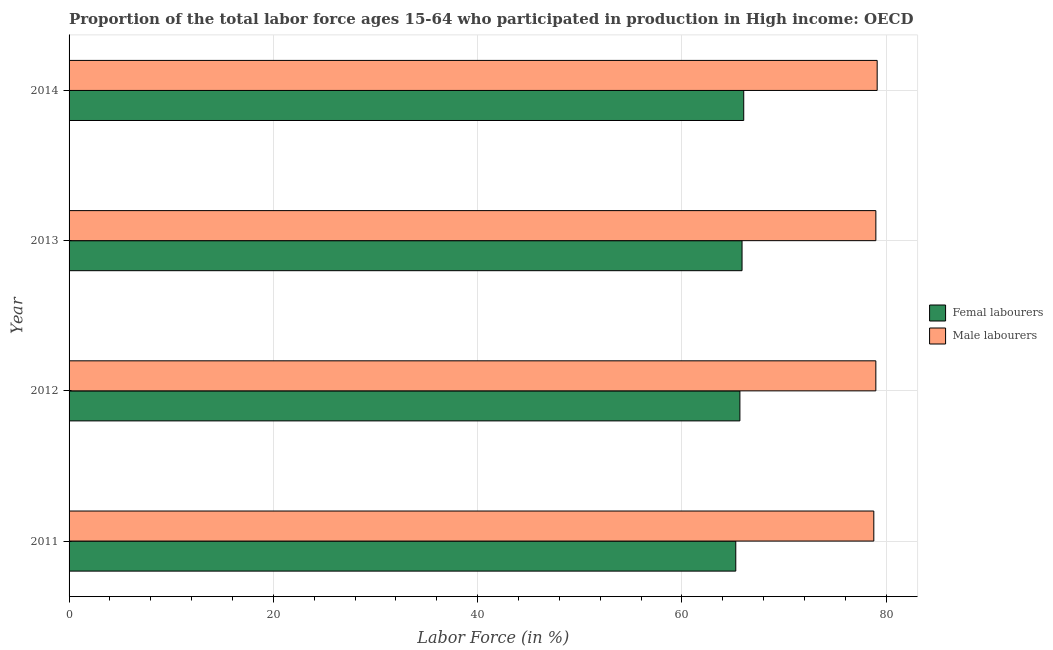What is the label of the 2nd group of bars from the top?
Ensure brevity in your answer.  2013. In how many cases, is the number of bars for a given year not equal to the number of legend labels?
Provide a short and direct response. 0. What is the percentage of female labor force in 2011?
Give a very brief answer. 65.28. Across all years, what is the maximum percentage of male labour force?
Provide a succinct answer. 79.12. Across all years, what is the minimum percentage of female labor force?
Your answer should be very brief. 65.28. In which year was the percentage of male labour force maximum?
Offer a terse response. 2014. What is the total percentage of female labor force in the graph?
Your answer should be very brief. 262.9. What is the difference between the percentage of female labor force in 2011 and that in 2014?
Your answer should be very brief. -0.78. What is the difference between the percentage of male labour force in 2012 and the percentage of female labor force in 2013?
Your response must be concise. 13.1. What is the average percentage of male labour force per year?
Make the answer very short. 78.97. In the year 2013, what is the difference between the percentage of female labor force and percentage of male labour force?
Offer a terse response. -13.1. What is the ratio of the percentage of female labor force in 2012 to that in 2013?
Your response must be concise. 1. Is the percentage of female labor force in 2012 less than that in 2013?
Make the answer very short. Yes. What is the difference between the highest and the second highest percentage of female labor force?
Provide a short and direct response. 0.17. What is the difference between the highest and the lowest percentage of female labor force?
Your answer should be very brief. 0.78. What does the 1st bar from the top in 2013 represents?
Give a very brief answer. Male labourers. What does the 2nd bar from the bottom in 2012 represents?
Offer a terse response. Male labourers. Are all the bars in the graph horizontal?
Offer a terse response. Yes. Does the graph contain any zero values?
Offer a terse response. No. Does the graph contain grids?
Your answer should be compact. Yes. Where does the legend appear in the graph?
Keep it short and to the point. Center right. How are the legend labels stacked?
Keep it short and to the point. Vertical. What is the title of the graph?
Provide a succinct answer. Proportion of the total labor force ages 15-64 who participated in production in High income: OECD. What is the Labor Force (in %) in Femal labourers in 2011?
Your response must be concise. 65.28. What is the Labor Force (in %) of Male labourers in 2011?
Make the answer very short. 78.79. What is the Labor Force (in %) of Femal labourers in 2012?
Your answer should be compact. 65.68. What is the Labor Force (in %) in Male labourers in 2012?
Provide a succinct answer. 78.99. What is the Labor Force (in %) of Femal labourers in 2013?
Ensure brevity in your answer.  65.89. What is the Labor Force (in %) of Male labourers in 2013?
Ensure brevity in your answer.  78.99. What is the Labor Force (in %) in Femal labourers in 2014?
Offer a terse response. 66.05. What is the Labor Force (in %) of Male labourers in 2014?
Give a very brief answer. 79.12. Across all years, what is the maximum Labor Force (in %) in Femal labourers?
Give a very brief answer. 66.05. Across all years, what is the maximum Labor Force (in %) in Male labourers?
Offer a very short reply. 79.12. Across all years, what is the minimum Labor Force (in %) in Femal labourers?
Offer a terse response. 65.28. Across all years, what is the minimum Labor Force (in %) of Male labourers?
Offer a terse response. 78.79. What is the total Labor Force (in %) of Femal labourers in the graph?
Your answer should be compact. 262.9. What is the total Labor Force (in %) of Male labourers in the graph?
Offer a very short reply. 315.88. What is the difference between the Labor Force (in %) in Femal labourers in 2011 and that in 2012?
Provide a succinct answer. -0.4. What is the difference between the Labor Force (in %) of Male labourers in 2011 and that in 2012?
Your response must be concise. -0.2. What is the difference between the Labor Force (in %) in Femal labourers in 2011 and that in 2013?
Provide a short and direct response. -0.61. What is the difference between the Labor Force (in %) in Male labourers in 2011 and that in 2013?
Keep it short and to the point. -0.2. What is the difference between the Labor Force (in %) in Femal labourers in 2011 and that in 2014?
Make the answer very short. -0.78. What is the difference between the Labor Force (in %) in Male labourers in 2011 and that in 2014?
Provide a short and direct response. -0.33. What is the difference between the Labor Force (in %) in Femal labourers in 2012 and that in 2013?
Ensure brevity in your answer.  -0.21. What is the difference between the Labor Force (in %) of Male labourers in 2012 and that in 2013?
Provide a succinct answer. -0. What is the difference between the Labor Force (in %) of Femal labourers in 2012 and that in 2014?
Ensure brevity in your answer.  -0.38. What is the difference between the Labor Force (in %) of Male labourers in 2012 and that in 2014?
Your answer should be very brief. -0.13. What is the difference between the Labor Force (in %) in Femal labourers in 2013 and that in 2014?
Your answer should be compact. -0.17. What is the difference between the Labor Force (in %) of Male labourers in 2013 and that in 2014?
Offer a very short reply. -0.13. What is the difference between the Labor Force (in %) of Femal labourers in 2011 and the Labor Force (in %) of Male labourers in 2012?
Ensure brevity in your answer.  -13.71. What is the difference between the Labor Force (in %) in Femal labourers in 2011 and the Labor Force (in %) in Male labourers in 2013?
Make the answer very short. -13.71. What is the difference between the Labor Force (in %) of Femal labourers in 2011 and the Labor Force (in %) of Male labourers in 2014?
Your answer should be compact. -13.84. What is the difference between the Labor Force (in %) in Femal labourers in 2012 and the Labor Force (in %) in Male labourers in 2013?
Your answer should be very brief. -13.31. What is the difference between the Labor Force (in %) in Femal labourers in 2012 and the Labor Force (in %) in Male labourers in 2014?
Your response must be concise. -13.44. What is the difference between the Labor Force (in %) in Femal labourers in 2013 and the Labor Force (in %) in Male labourers in 2014?
Your answer should be very brief. -13.23. What is the average Labor Force (in %) in Femal labourers per year?
Your answer should be compact. 65.72. What is the average Labor Force (in %) of Male labourers per year?
Provide a succinct answer. 78.97. In the year 2011, what is the difference between the Labor Force (in %) of Femal labourers and Labor Force (in %) of Male labourers?
Provide a short and direct response. -13.51. In the year 2012, what is the difference between the Labor Force (in %) in Femal labourers and Labor Force (in %) in Male labourers?
Offer a very short reply. -13.31. In the year 2013, what is the difference between the Labor Force (in %) of Femal labourers and Labor Force (in %) of Male labourers?
Make the answer very short. -13.1. In the year 2014, what is the difference between the Labor Force (in %) of Femal labourers and Labor Force (in %) of Male labourers?
Provide a succinct answer. -13.06. What is the ratio of the Labor Force (in %) in Male labourers in 2011 to that in 2013?
Ensure brevity in your answer.  1. What is the ratio of the Labor Force (in %) of Femal labourers in 2011 to that in 2014?
Offer a very short reply. 0.99. What is the ratio of the Labor Force (in %) of Femal labourers in 2012 to that in 2013?
Provide a short and direct response. 1. What is the ratio of the Labor Force (in %) of Femal labourers in 2012 to that in 2014?
Make the answer very short. 0.99. What is the ratio of the Labor Force (in %) in Femal labourers in 2013 to that in 2014?
Make the answer very short. 1. What is the ratio of the Labor Force (in %) in Male labourers in 2013 to that in 2014?
Make the answer very short. 1. What is the difference between the highest and the second highest Labor Force (in %) in Femal labourers?
Provide a short and direct response. 0.17. What is the difference between the highest and the second highest Labor Force (in %) of Male labourers?
Your answer should be compact. 0.13. What is the difference between the highest and the lowest Labor Force (in %) of Femal labourers?
Make the answer very short. 0.78. What is the difference between the highest and the lowest Labor Force (in %) in Male labourers?
Keep it short and to the point. 0.33. 